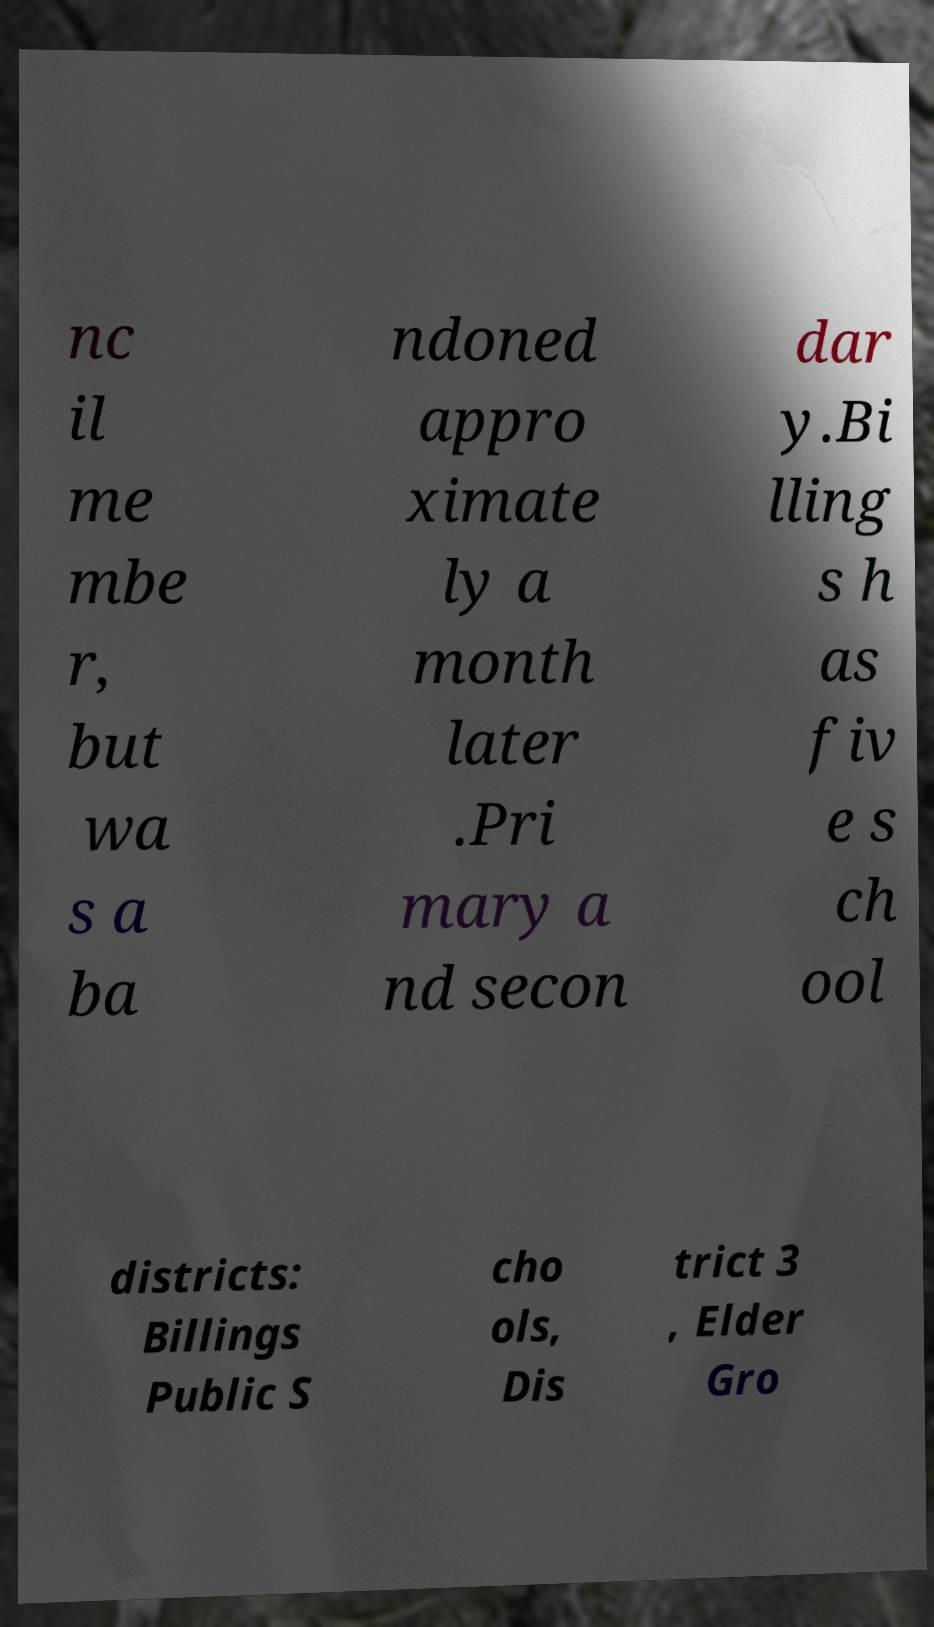There's text embedded in this image that I need extracted. Can you transcribe it verbatim? nc il me mbe r, but wa s a ba ndoned appro ximate ly a month later .Pri mary a nd secon dar y.Bi lling s h as fiv e s ch ool districts: Billings Public S cho ols, Dis trict 3 , Elder Gro 